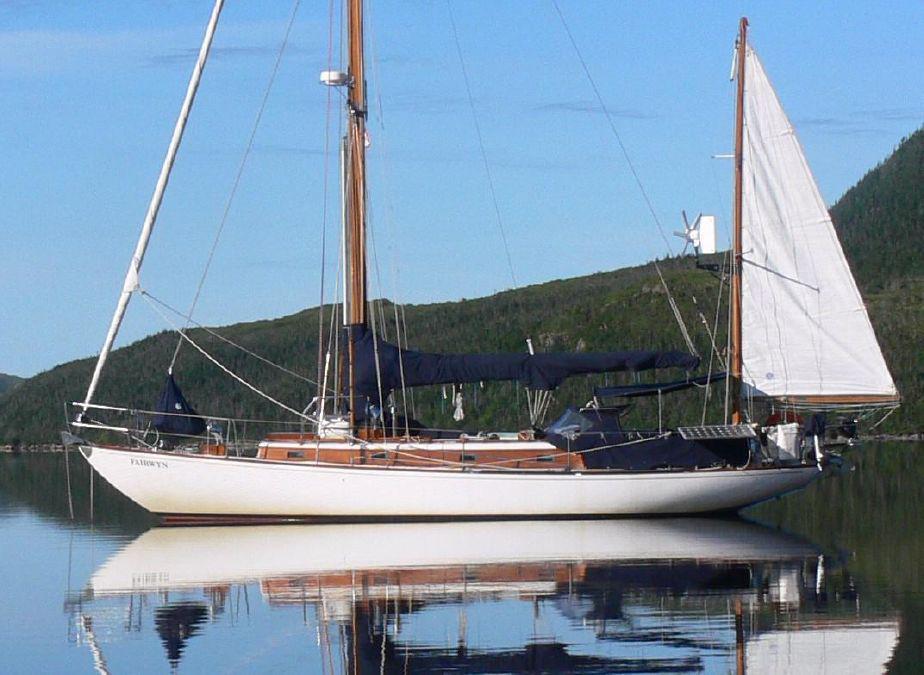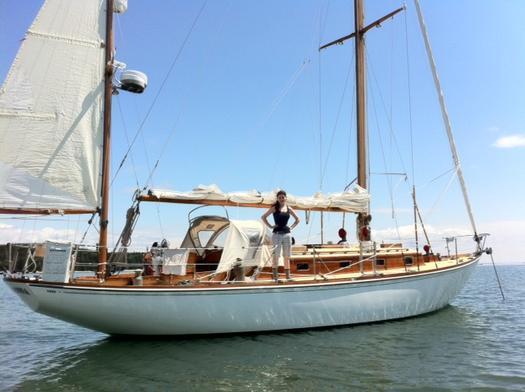The first image is the image on the left, the second image is the image on the right. Examine the images to the left and right. Is the description "Hilly land is visible behind one of the boats." accurate? Answer yes or no. Yes. 